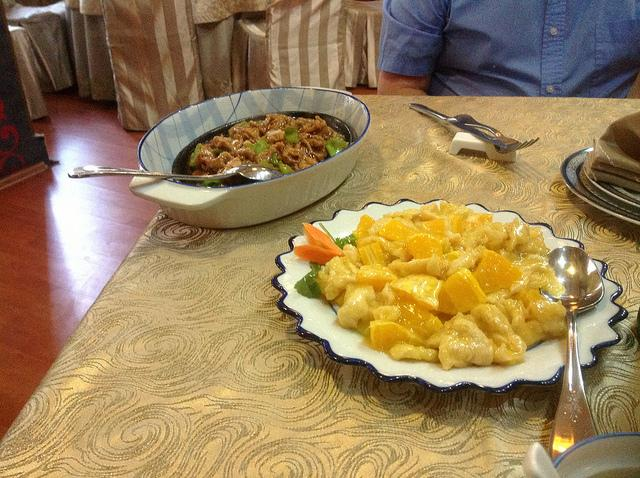What utensil is missing from this table?

Choices:
A) knife
B) fork
C) plate
D) spoon knife 